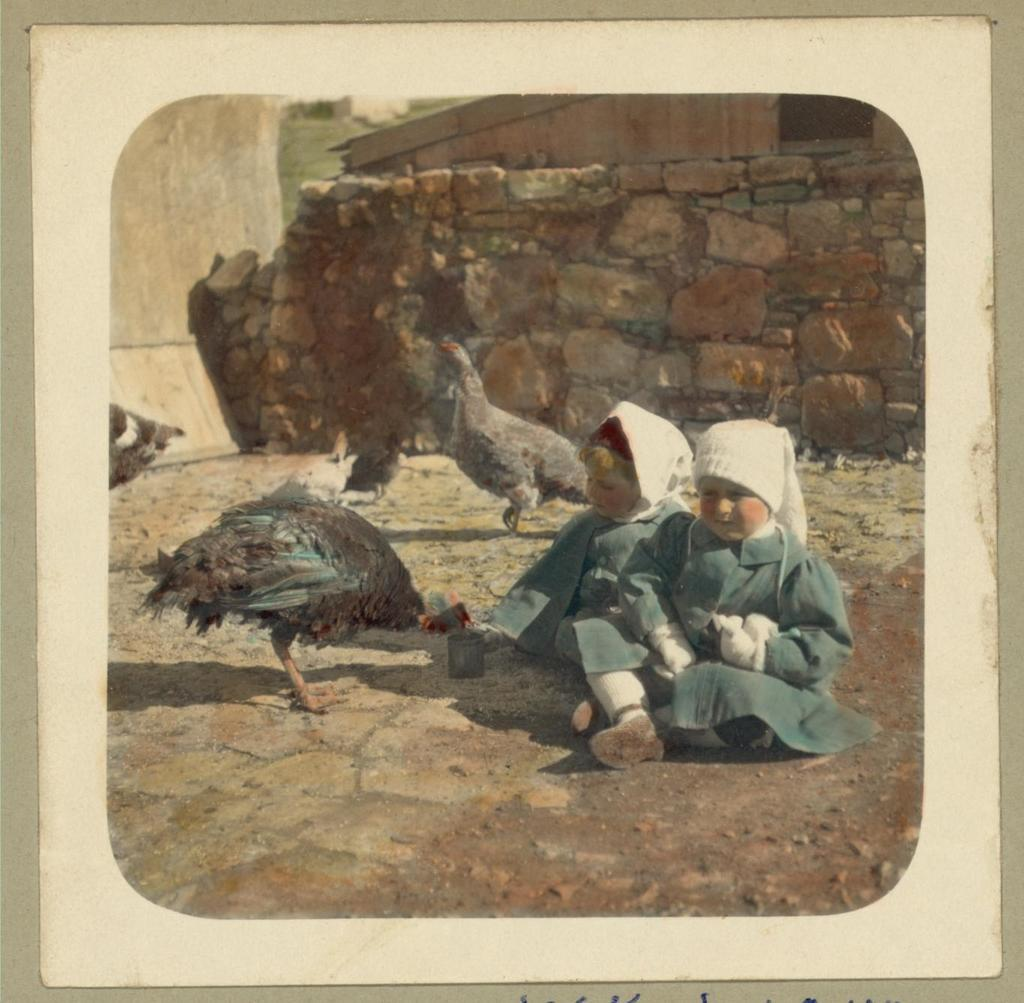How many people are present in the image? There are two girls sitting in the image. What might the girls be pretending to be or dressed as? The girls may be wearing costumes or posing as hens. What can be seen in the background of the image? There is a wall in the background of the image. What material is the wall made of? The wall appears to be built with rocks. Is there any smoke coming from the tiger's mouth in the image? There is no tiger present in the image, so there is no smoke coming from its mouth. 